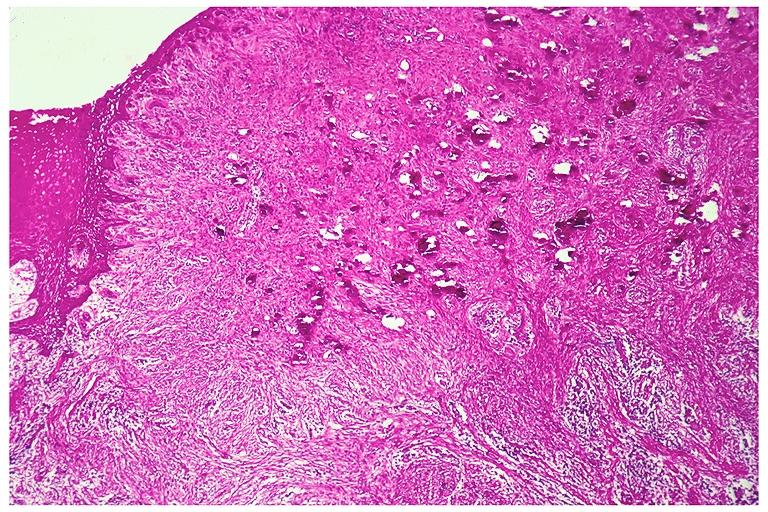does this image show peripheral cemento-ossifying fibroma?
Answer the question using a single word or phrase. Yes 